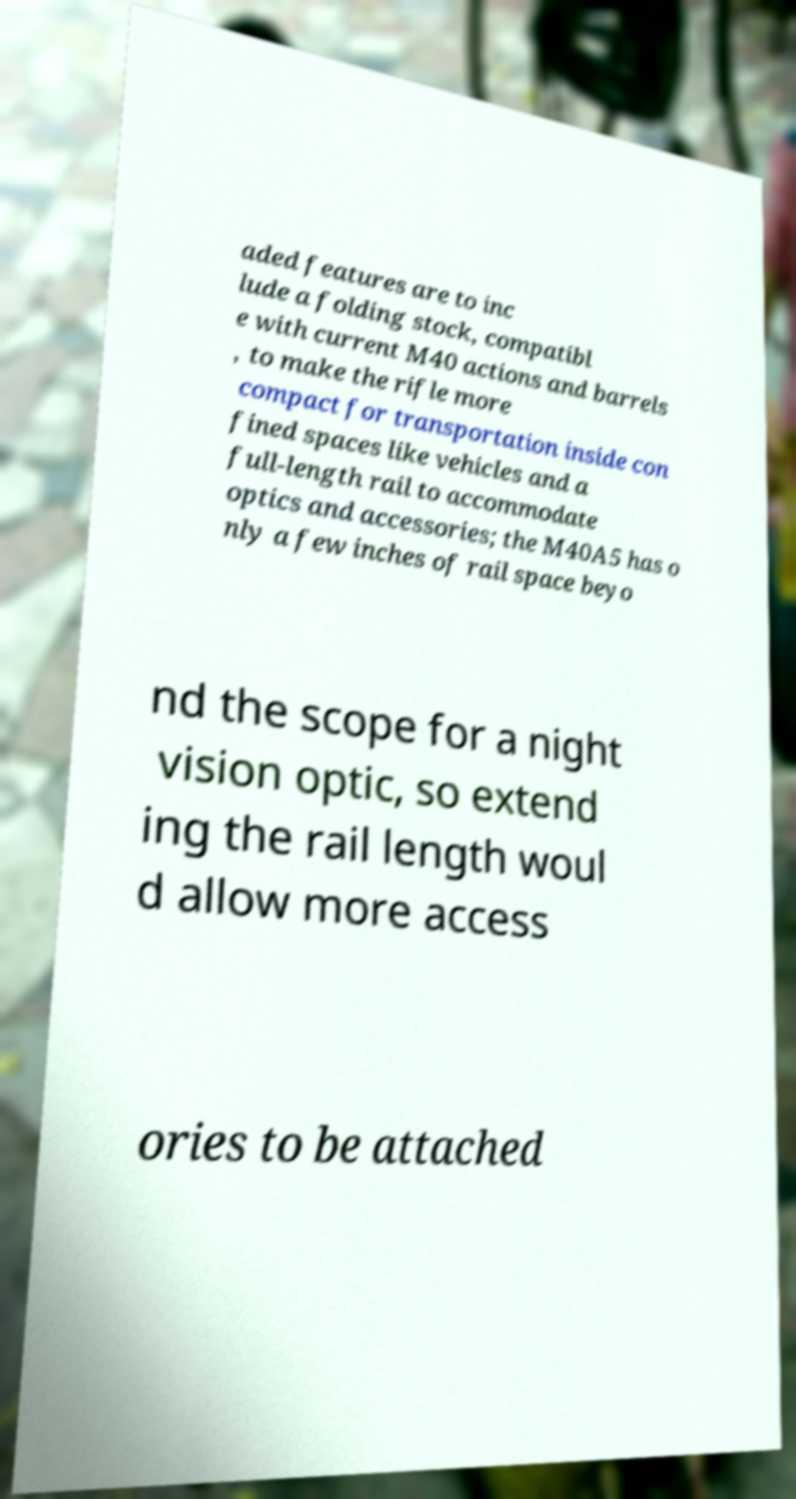Please identify and transcribe the text found in this image. aded features are to inc lude a folding stock, compatibl e with current M40 actions and barrels , to make the rifle more compact for transportation inside con fined spaces like vehicles and a full-length rail to accommodate optics and accessories; the M40A5 has o nly a few inches of rail space beyo nd the scope for a night vision optic, so extend ing the rail length woul d allow more access ories to be attached 